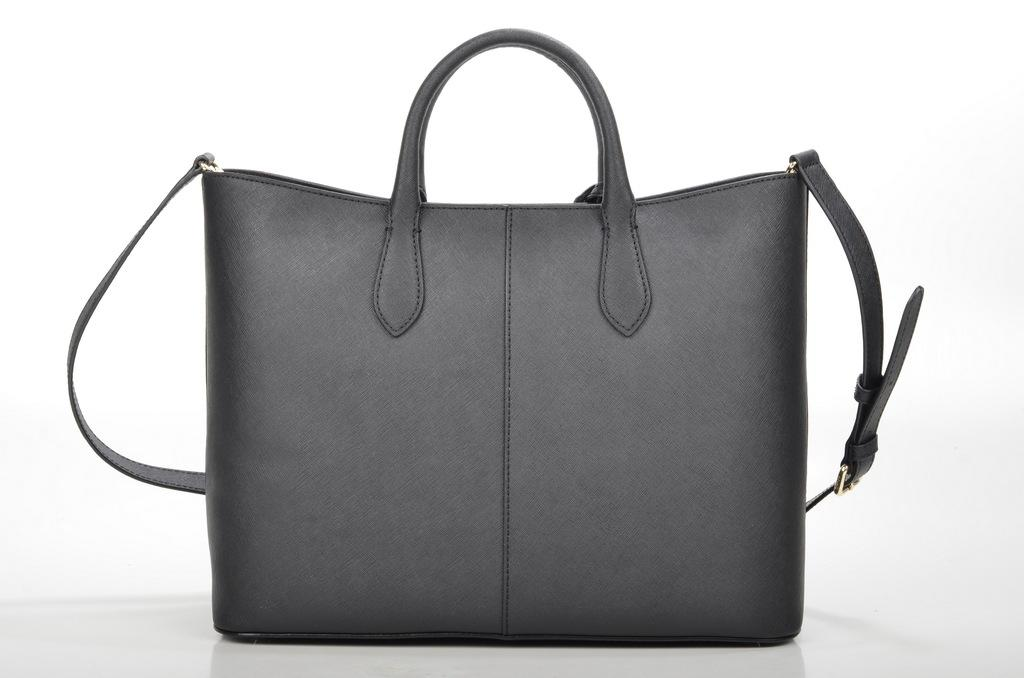What object is present in the image? There is a bag in the image. What feature does the bag have to secure it? The bag has a belt. How can the bag be carried? The bag has a strap for carrying. How many eyes can be seen on the bag in the image? There are no eyes visible on the bag in the image. 